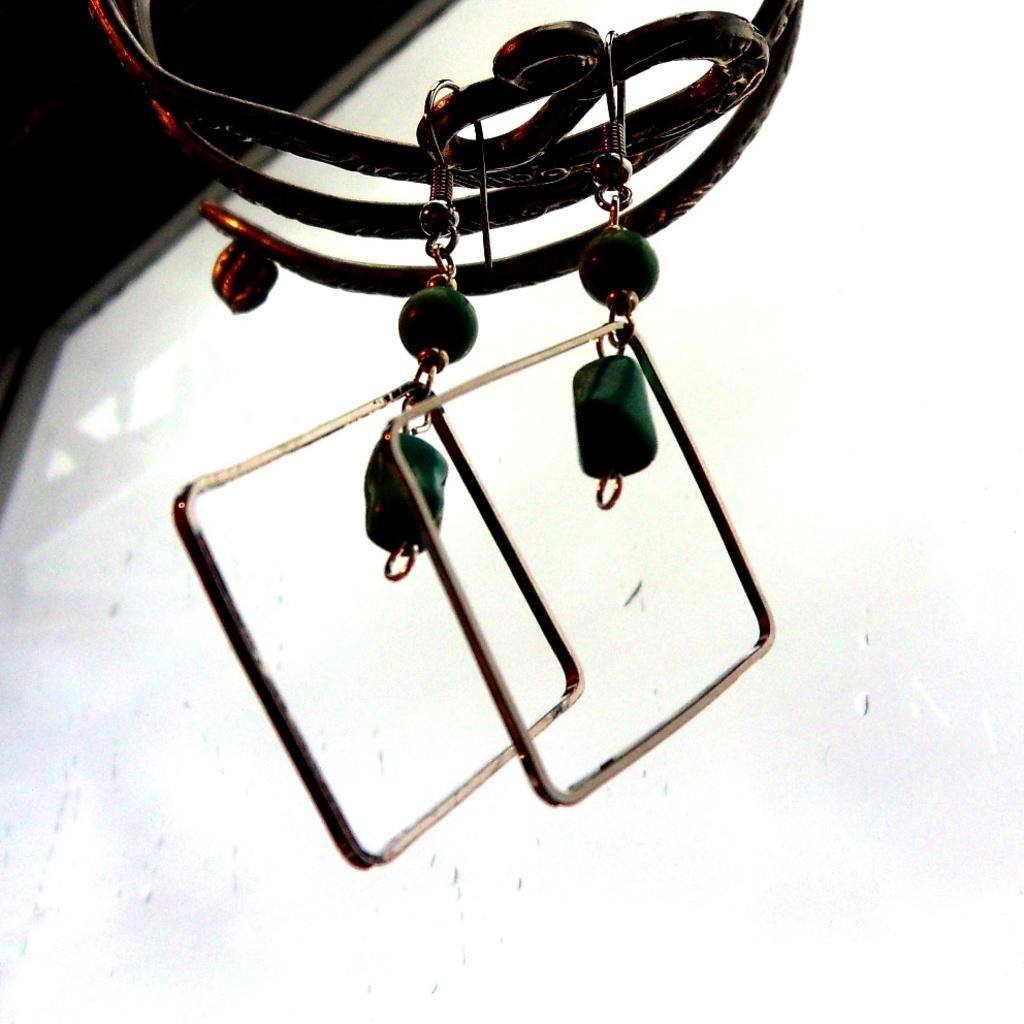What type of accessory is visible in the image? There are earrings in the image. Can you describe the design of the earrings? The earrings have a screen-like appearance on the back side. How many dogs are visible in the image? There are no dogs present in the image; it only features earrings. What type of wound can be seen on the earrings in the image? There is no wound visible on the earrings in the image; they have a screen-like appearance on the back side. 